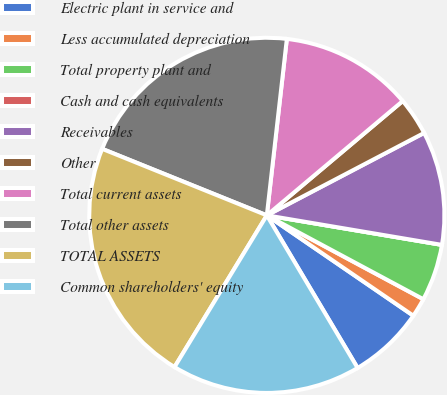<chart> <loc_0><loc_0><loc_500><loc_500><pie_chart><fcel>Electric plant in service and<fcel>Less accumulated depreciation<fcel>Total property plant and<fcel>Cash and cash equivalents<fcel>Receivables<fcel>Other<fcel>Total current assets<fcel>Total other assets<fcel>TOTAL ASSETS<fcel>Common shareholders' equity<nl><fcel>6.9%<fcel>1.73%<fcel>5.17%<fcel>0.0%<fcel>10.34%<fcel>3.45%<fcel>12.07%<fcel>20.69%<fcel>22.41%<fcel>17.24%<nl></chart> 